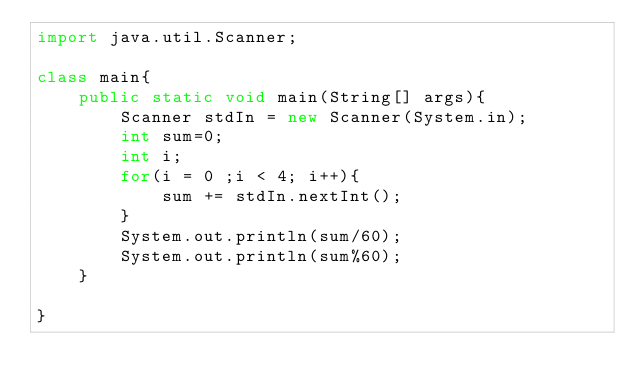<code> <loc_0><loc_0><loc_500><loc_500><_Java_>import java.util.Scanner;

class main{
	public static void main(String[] args){
		Scanner stdIn = new Scanner(System.in);
		int sum=0;
		int i;
		for(i = 0 ;i < 4; i++){
			sum += stdIn.nextInt();
		}
		System.out.println(sum/60);
		System.out.println(sum%60);
	}

}</code> 